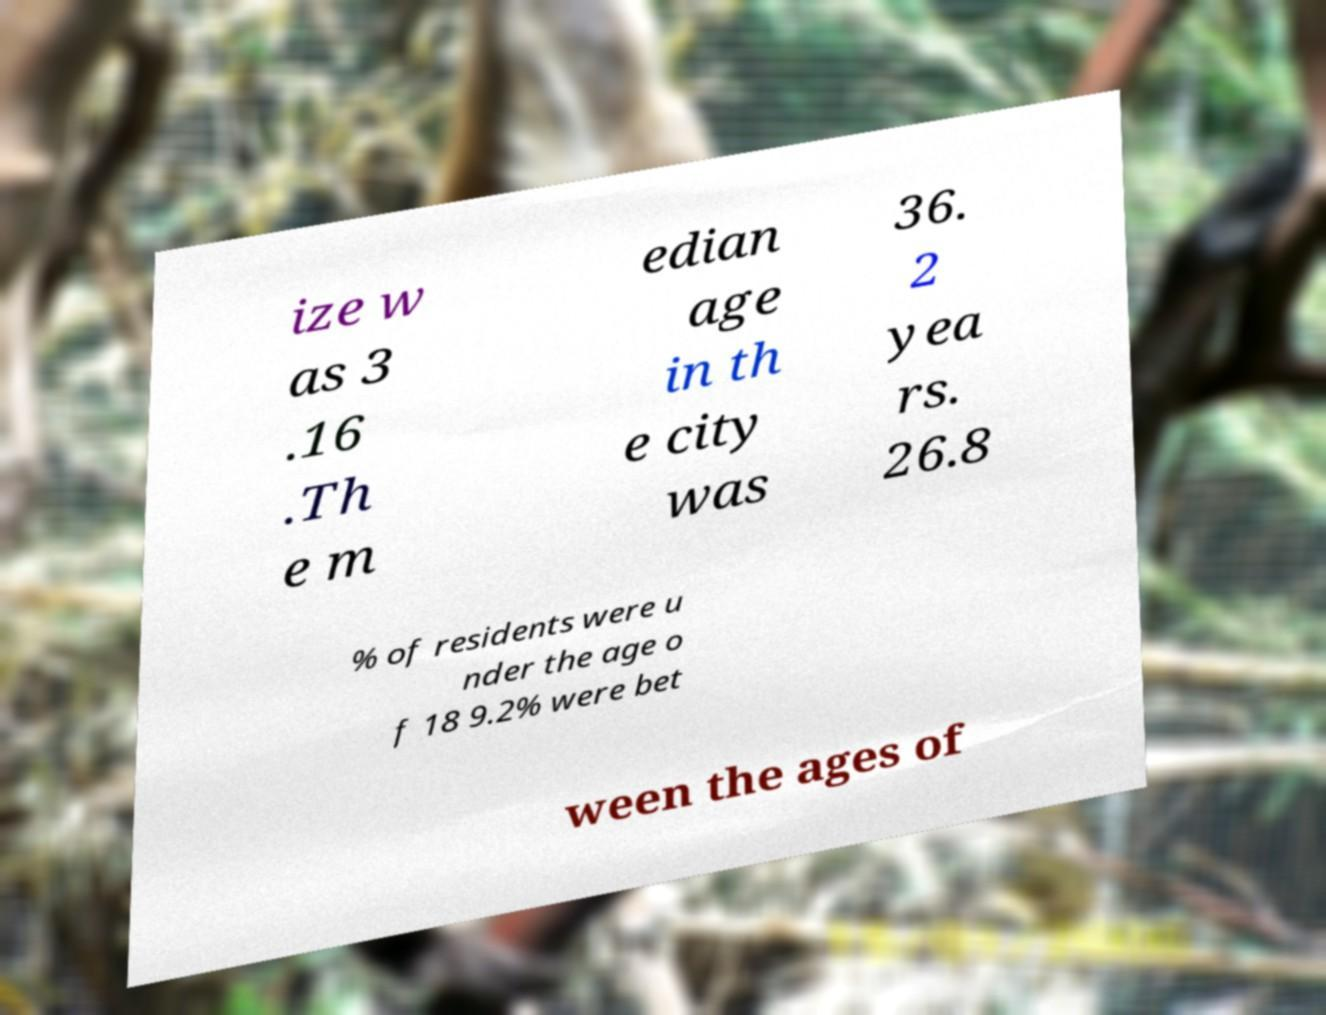What messages or text are displayed in this image? I need them in a readable, typed format. ize w as 3 .16 .Th e m edian age in th e city was 36. 2 yea rs. 26.8 % of residents were u nder the age o f 18 9.2% were bet ween the ages of 